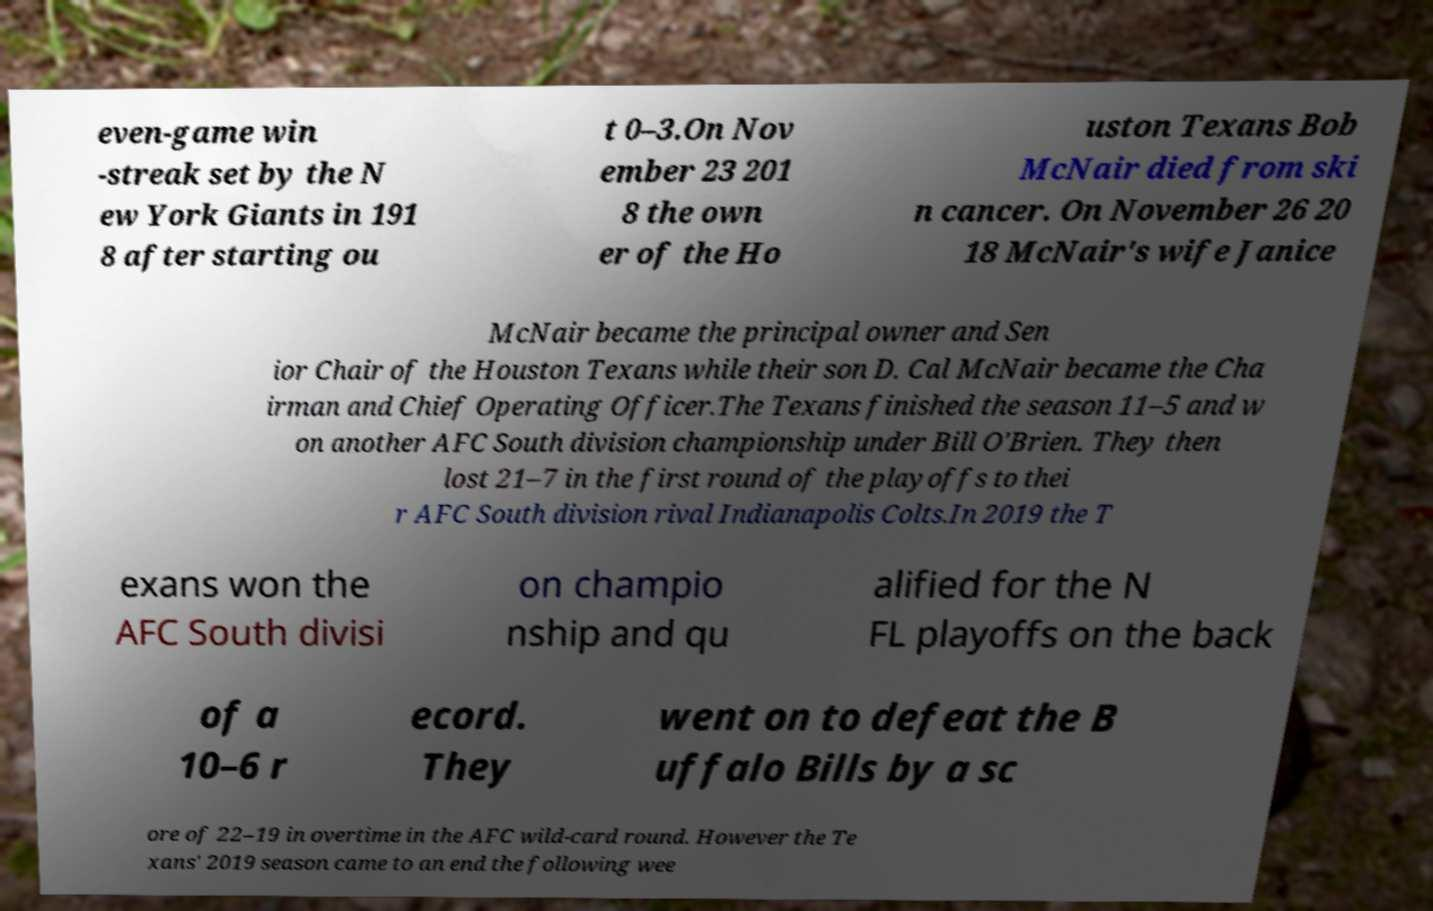Could you extract and type out the text from this image? even-game win -streak set by the N ew York Giants in 191 8 after starting ou t 0–3.On Nov ember 23 201 8 the own er of the Ho uston Texans Bob McNair died from ski n cancer. On November 26 20 18 McNair's wife Janice McNair became the principal owner and Sen ior Chair of the Houston Texans while their son D. Cal McNair became the Cha irman and Chief Operating Officer.The Texans finished the season 11–5 and w on another AFC South division championship under Bill O'Brien. They then lost 21–7 in the first round of the playoffs to thei r AFC South division rival Indianapolis Colts.In 2019 the T exans won the AFC South divisi on champio nship and qu alified for the N FL playoffs on the back of a 10–6 r ecord. They went on to defeat the B uffalo Bills by a sc ore of 22–19 in overtime in the AFC wild-card round. However the Te xans' 2019 season came to an end the following wee 